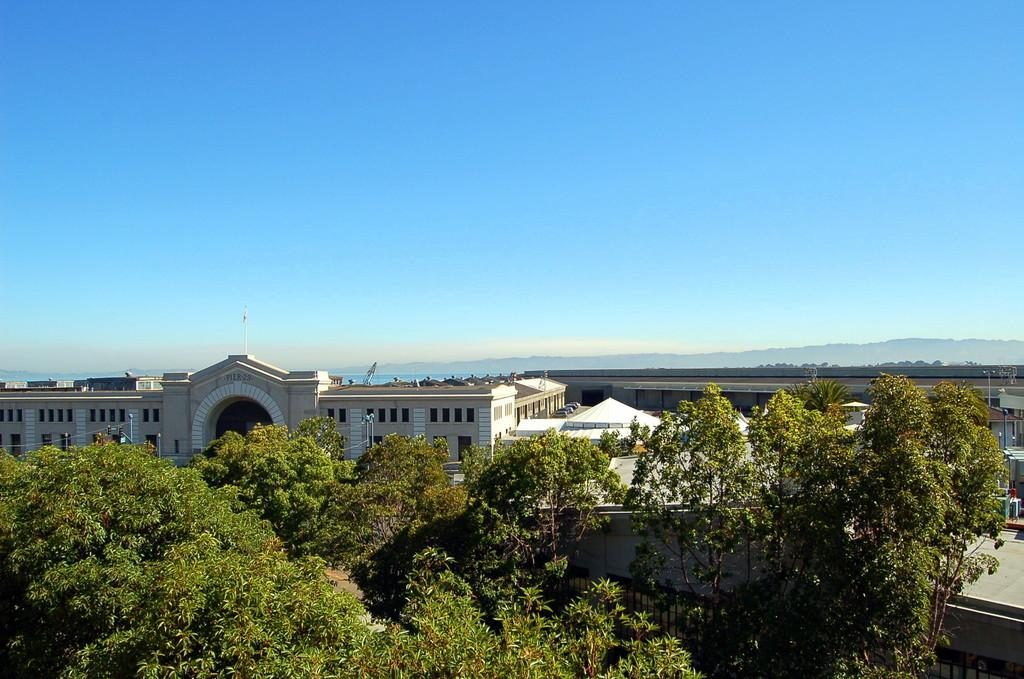What type of structures can be seen in the image? There are buildings in the image. What natural elements are present in the image? There are a lot of trees in the image. What grade of wrench is being used to adjust the coastline in the image? There is no wrench or coastline present in the image; it features buildings and trees. 